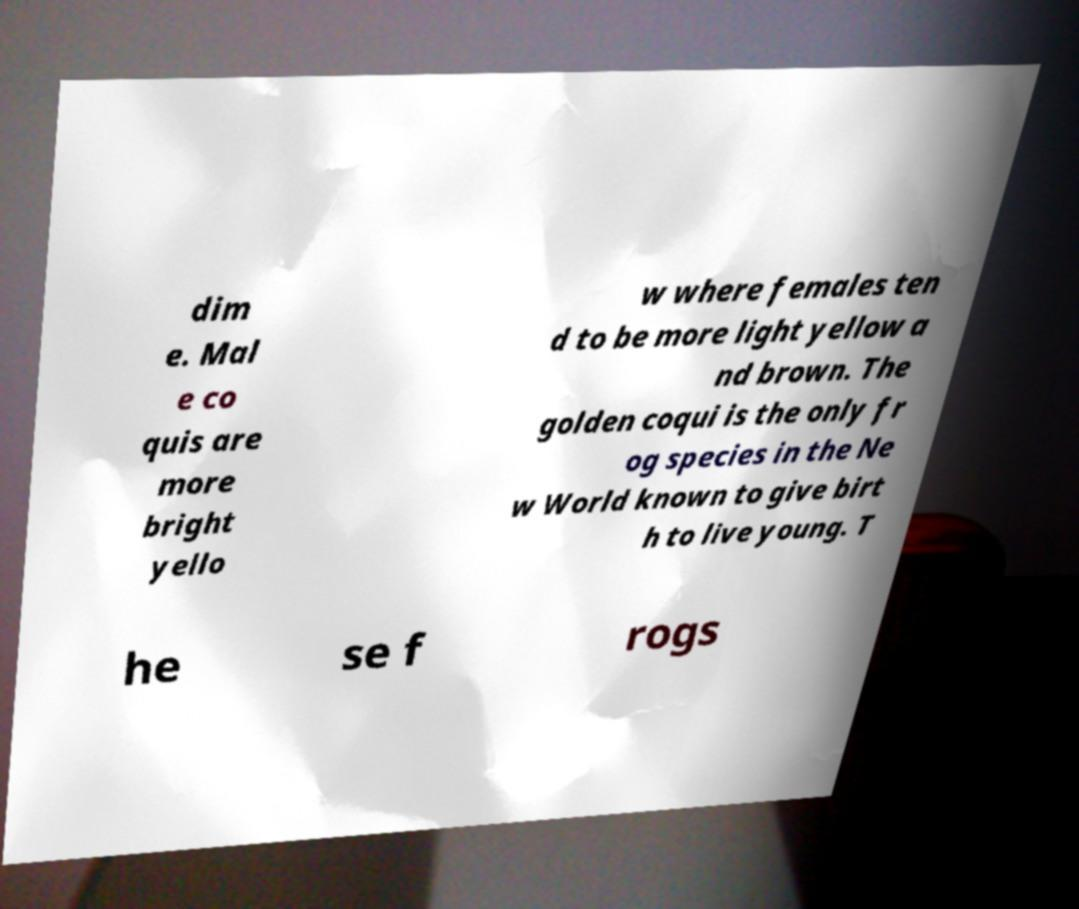Can you accurately transcribe the text from the provided image for me? dim e. Mal e co quis are more bright yello w where females ten d to be more light yellow a nd brown. The golden coqui is the only fr og species in the Ne w World known to give birt h to live young. T he se f rogs 